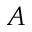Convert formula to latex. <formula><loc_0><loc_0><loc_500><loc_500>A</formula> 